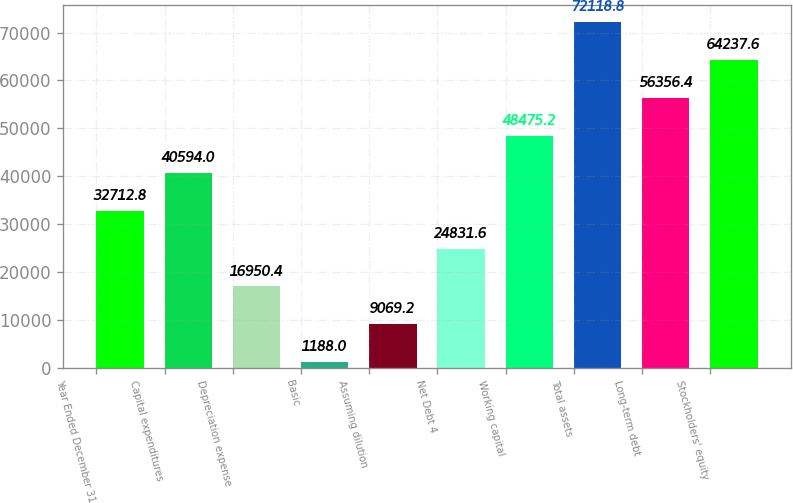Convert chart to OTSL. <chart><loc_0><loc_0><loc_500><loc_500><bar_chart><fcel>Year Ended December 31<fcel>Capital expenditures<fcel>Depreciation expense<fcel>Basic<fcel>Assuming dilution<fcel>Net Debt 4<fcel>Working capital<fcel>Total assets<fcel>Long-term debt<fcel>Stockholders' equity<nl><fcel>32712.8<fcel>40594<fcel>16950.4<fcel>1188<fcel>9069.2<fcel>24831.6<fcel>48475.2<fcel>72118.8<fcel>56356.4<fcel>64237.6<nl></chart> 